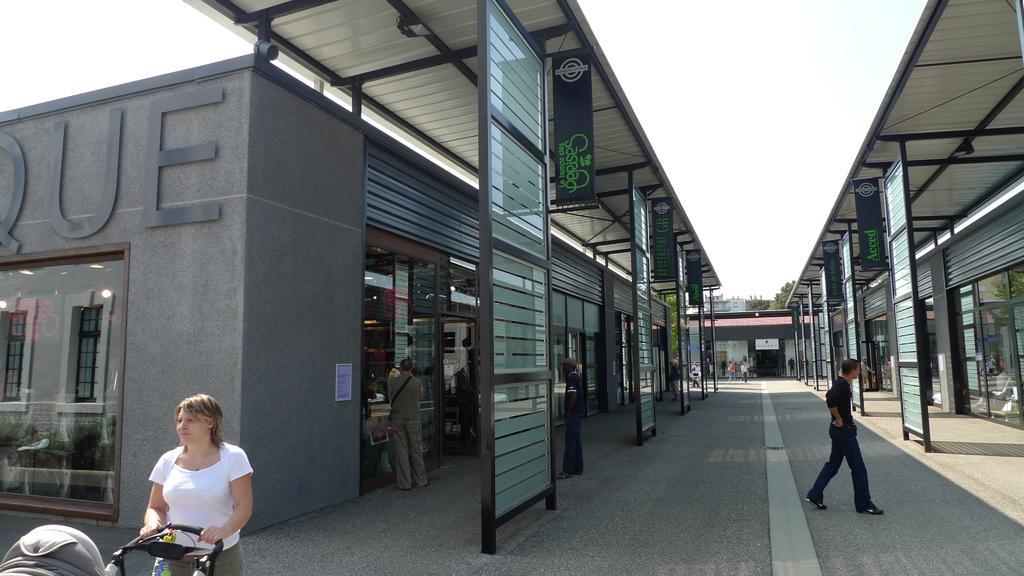Describe this image in one or two sentences. In this picture I can see group of people standing, a person holding a stroller, and there are houses, boards, trees, and in the background there is sky. 